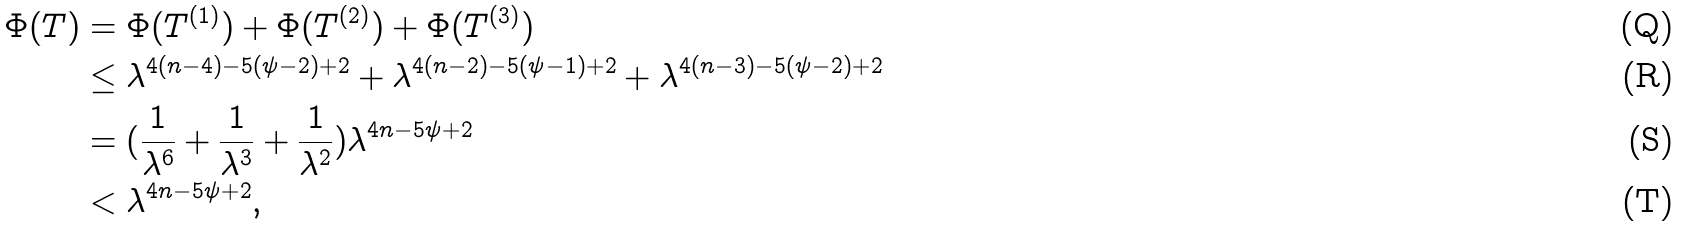Convert formula to latex. <formula><loc_0><loc_0><loc_500><loc_500>\Phi ( T ) & = \Phi ( T ^ { ( 1 ) } ) + \Phi ( T ^ { ( 2 ) } ) + \Phi ( T ^ { ( 3 ) } ) \\ & \leq \lambda ^ { 4 ( n - 4 ) - 5 ( \psi - 2 ) + 2 } + \lambda ^ { 4 ( n - 2 ) - 5 ( \psi - 1 ) + 2 } + \lambda ^ { 4 ( n - 3 ) - 5 ( \psi - 2 ) + 2 } \\ & = ( \frac { 1 } { \lambda ^ { 6 } } + \frac { 1 } { \lambda ^ { 3 } } + \frac { 1 } { \lambda ^ { 2 } } ) \lambda ^ { 4 n - 5 \psi + 2 } \\ & < \lambda ^ { 4 n - 5 \psi + 2 } ,</formula> 